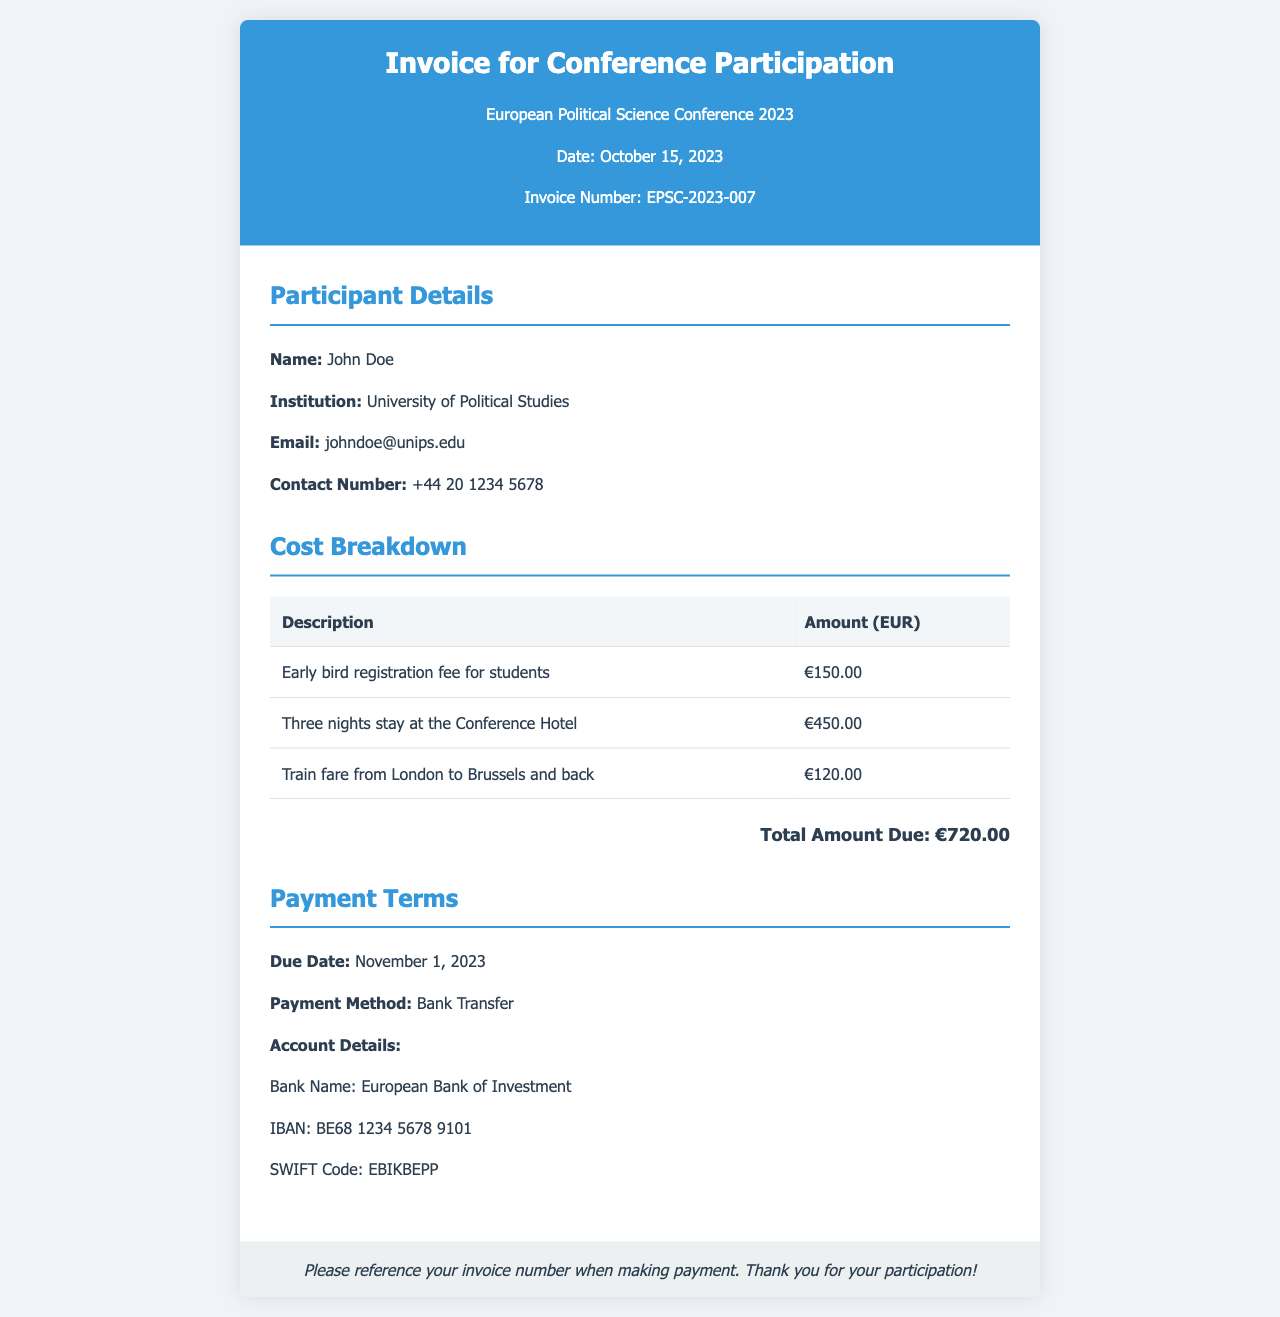What is the conference name? The conference name is stated in the header of the invoice.
Answer: European Political Science Conference 2023 What is the invoice number? The invoice number is provided in the header section of the invoice.
Answer: EPSC-2023-007 Who is the participant? The name of the participant is mentioned in the participant details section.
Answer: John Doe What is the total amount due? The total amount is calculated and shown in the cost breakdown section.
Answer: €720.00 What is the due date for payment? The due date for payment is mentioned in the payment terms section.
Answer: November 1, 2023 How much is the registration fee? The fee for registration is detailed in the cost breakdown table.
Answer: €150.00 What payment method is accepted? The accepted payment method is specified under the payment terms.
Answer: Bank Transfer What is the accommodation cost? The accommodation cost is listed in the cost breakdown table.
Answer: €450.00 What is the train fare mentioned? The train fare amount is specified in the cost breakdown section.
Answer: €120.00 